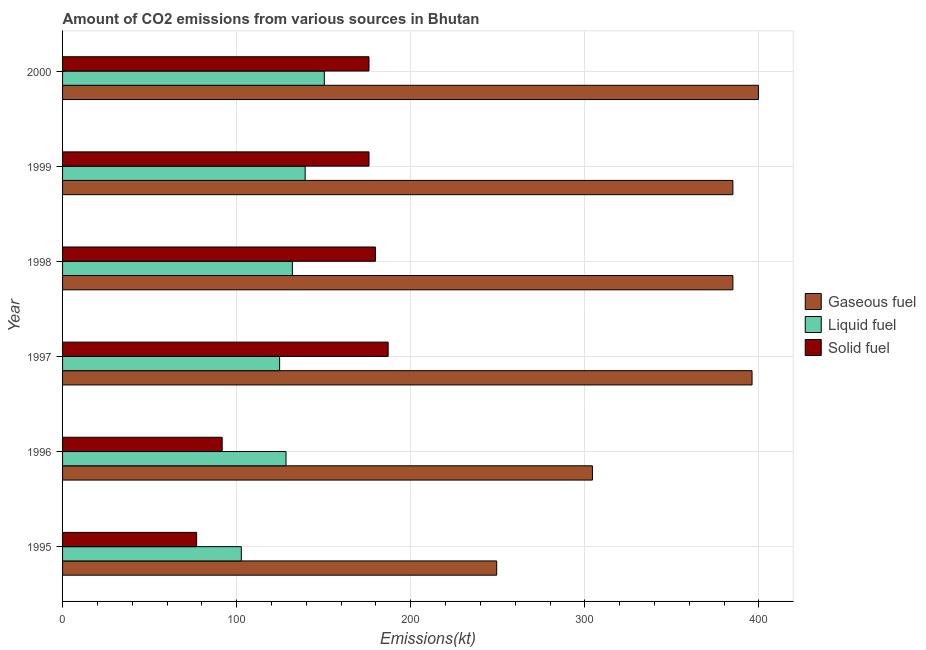How many bars are there on the 1st tick from the bottom?
Keep it short and to the point. 3. What is the label of the 6th group of bars from the top?
Your response must be concise. 1995. What is the amount of co2 emissions from solid fuel in 1998?
Your answer should be compact. 179.68. Across all years, what is the maximum amount of co2 emissions from solid fuel?
Offer a very short reply. 187.02. Across all years, what is the minimum amount of co2 emissions from gaseous fuel?
Your answer should be very brief. 249.36. In which year was the amount of co2 emissions from gaseous fuel minimum?
Offer a terse response. 1995. What is the total amount of co2 emissions from gaseous fuel in the graph?
Provide a short and direct response. 2119.53. What is the difference between the amount of co2 emissions from gaseous fuel in 1999 and that in 2000?
Offer a terse response. -14.67. What is the difference between the amount of co2 emissions from liquid fuel in 1998 and the amount of co2 emissions from solid fuel in 1999?
Ensure brevity in your answer.  -44. What is the average amount of co2 emissions from solid fuel per year?
Provide a short and direct response. 147.9. In the year 1995, what is the difference between the amount of co2 emissions from liquid fuel and amount of co2 emissions from gaseous fuel?
Your response must be concise. -146.68. What is the difference between the highest and the second highest amount of co2 emissions from solid fuel?
Your answer should be compact. 7.33. What is the difference between the highest and the lowest amount of co2 emissions from liquid fuel?
Provide a succinct answer. 47.67. Is the sum of the amount of co2 emissions from gaseous fuel in 1996 and 1998 greater than the maximum amount of co2 emissions from solid fuel across all years?
Provide a succinct answer. Yes. What does the 1st bar from the top in 1996 represents?
Keep it short and to the point. Solid fuel. What does the 1st bar from the bottom in 1997 represents?
Your answer should be compact. Gaseous fuel. How many bars are there?
Keep it short and to the point. 18. Are the values on the major ticks of X-axis written in scientific E-notation?
Keep it short and to the point. No. Does the graph contain grids?
Your answer should be very brief. Yes. Where does the legend appear in the graph?
Give a very brief answer. Center right. What is the title of the graph?
Keep it short and to the point. Amount of CO2 emissions from various sources in Bhutan. Does "Spain" appear as one of the legend labels in the graph?
Make the answer very short. No. What is the label or title of the X-axis?
Your answer should be very brief. Emissions(kt). What is the label or title of the Y-axis?
Keep it short and to the point. Year. What is the Emissions(kt) in Gaseous fuel in 1995?
Ensure brevity in your answer.  249.36. What is the Emissions(kt) of Liquid fuel in 1995?
Offer a very short reply. 102.68. What is the Emissions(kt) in Solid fuel in 1995?
Provide a succinct answer. 77.01. What is the Emissions(kt) in Gaseous fuel in 1996?
Your response must be concise. 304.36. What is the Emissions(kt) in Liquid fuel in 1996?
Give a very brief answer. 128.34. What is the Emissions(kt) of Solid fuel in 1996?
Offer a very short reply. 91.67. What is the Emissions(kt) of Gaseous fuel in 1997?
Make the answer very short. 396.04. What is the Emissions(kt) in Liquid fuel in 1997?
Provide a succinct answer. 124.68. What is the Emissions(kt) in Solid fuel in 1997?
Ensure brevity in your answer.  187.02. What is the Emissions(kt) in Gaseous fuel in 1998?
Provide a succinct answer. 385.04. What is the Emissions(kt) of Liquid fuel in 1998?
Keep it short and to the point. 132.01. What is the Emissions(kt) in Solid fuel in 1998?
Provide a short and direct response. 179.68. What is the Emissions(kt) in Gaseous fuel in 1999?
Give a very brief answer. 385.04. What is the Emissions(kt) in Liquid fuel in 1999?
Offer a terse response. 139.35. What is the Emissions(kt) of Solid fuel in 1999?
Make the answer very short. 176.02. What is the Emissions(kt) of Gaseous fuel in 2000?
Keep it short and to the point. 399.7. What is the Emissions(kt) in Liquid fuel in 2000?
Your response must be concise. 150.35. What is the Emissions(kt) in Solid fuel in 2000?
Your answer should be compact. 176.02. Across all years, what is the maximum Emissions(kt) of Gaseous fuel?
Provide a succinct answer. 399.7. Across all years, what is the maximum Emissions(kt) of Liquid fuel?
Make the answer very short. 150.35. Across all years, what is the maximum Emissions(kt) in Solid fuel?
Keep it short and to the point. 187.02. Across all years, what is the minimum Emissions(kt) of Gaseous fuel?
Offer a terse response. 249.36. Across all years, what is the minimum Emissions(kt) of Liquid fuel?
Your answer should be compact. 102.68. Across all years, what is the minimum Emissions(kt) of Solid fuel?
Provide a short and direct response. 77.01. What is the total Emissions(kt) in Gaseous fuel in the graph?
Offer a very short reply. 2119.53. What is the total Emissions(kt) of Liquid fuel in the graph?
Provide a succinct answer. 777.4. What is the total Emissions(kt) in Solid fuel in the graph?
Provide a short and direct response. 887.41. What is the difference between the Emissions(kt) of Gaseous fuel in 1995 and that in 1996?
Provide a short and direct response. -55.01. What is the difference between the Emissions(kt) of Liquid fuel in 1995 and that in 1996?
Offer a very short reply. -25.67. What is the difference between the Emissions(kt) in Solid fuel in 1995 and that in 1996?
Your response must be concise. -14.67. What is the difference between the Emissions(kt) of Gaseous fuel in 1995 and that in 1997?
Provide a succinct answer. -146.68. What is the difference between the Emissions(kt) in Liquid fuel in 1995 and that in 1997?
Give a very brief answer. -22. What is the difference between the Emissions(kt) of Solid fuel in 1995 and that in 1997?
Your answer should be very brief. -110.01. What is the difference between the Emissions(kt) of Gaseous fuel in 1995 and that in 1998?
Make the answer very short. -135.68. What is the difference between the Emissions(kt) in Liquid fuel in 1995 and that in 1998?
Give a very brief answer. -29.34. What is the difference between the Emissions(kt) in Solid fuel in 1995 and that in 1998?
Give a very brief answer. -102.68. What is the difference between the Emissions(kt) of Gaseous fuel in 1995 and that in 1999?
Keep it short and to the point. -135.68. What is the difference between the Emissions(kt) in Liquid fuel in 1995 and that in 1999?
Ensure brevity in your answer.  -36.67. What is the difference between the Emissions(kt) in Solid fuel in 1995 and that in 1999?
Give a very brief answer. -99.01. What is the difference between the Emissions(kt) of Gaseous fuel in 1995 and that in 2000?
Offer a very short reply. -150.35. What is the difference between the Emissions(kt) of Liquid fuel in 1995 and that in 2000?
Provide a short and direct response. -47.67. What is the difference between the Emissions(kt) in Solid fuel in 1995 and that in 2000?
Give a very brief answer. -99.01. What is the difference between the Emissions(kt) in Gaseous fuel in 1996 and that in 1997?
Keep it short and to the point. -91.67. What is the difference between the Emissions(kt) in Liquid fuel in 1996 and that in 1997?
Offer a terse response. 3.67. What is the difference between the Emissions(kt) of Solid fuel in 1996 and that in 1997?
Your answer should be compact. -95.34. What is the difference between the Emissions(kt) in Gaseous fuel in 1996 and that in 1998?
Offer a very short reply. -80.67. What is the difference between the Emissions(kt) of Liquid fuel in 1996 and that in 1998?
Keep it short and to the point. -3.67. What is the difference between the Emissions(kt) of Solid fuel in 1996 and that in 1998?
Your answer should be very brief. -88.01. What is the difference between the Emissions(kt) of Gaseous fuel in 1996 and that in 1999?
Offer a terse response. -80.67. What is the difference between the Emissions(kt) in Liquid fuel in 1996 and that in 1999?
Provide a short and direct response. -11. What is the difference between the Emissions(kt) in Solid fuel in 1996 and that in 1999?
Ensure brevity in your answer.  -84.34. What is the difference between the Emissions(kt) in Gaseous fuel in 1996 and that in 2000?
Keep it short and to the point. -95.34. What is the difference between the Emissions(kt) in Liquid fuel in 1996 and that in 2000?
Provide a short and direct response. -22. What is the difference between the Emissions(kt) of Solid fuel in 1996 and that in 2000?
Provide a succinct answer. -84.34. What is the difference between the Emissions(kt) in Gaseous fuel in 1997 and that in 1998?
Provide a short and direct response. 11. What is the difference between the Emissions(kt) of Liquid fuel in 1997 and that in 1998?
Offer a very short reply. -7.33. What is the difference between the Emissions(kt) of Solid fuel in 1997 and that in 1998?
Provide a short and direct response. 7.33. What is the difference between the Emissions(kt) of Gaseous fuel in 1997 and that in 1999?
Offer a terse response. 11. What is the difference between the Emissions(kt) in Liquid fuel in 1997 and that in 1999?
Keep it short and to the point. -14.67. What is the difference between the Emissions(kt) of Solid fuel in 1997 and that in 1999?
Your response must be concise. 11. What is the difference between the Emissions(kt) of Gaseous fuel in 1997 and that in 2000?
Keep it short and to the point. -3.67. What is the difference between the Emissions(kt) of Liquid fuel in 1997 and that in 2000?
Ensure brevity in your answer.  -25.67. What is the difference between the Emissions(kt) of Solid fuel in 1997 and that in 2000?
Give a very brief answer. 11. What is the difference between the Emissions(kt) of Liquid fuel in 1998 and that in 1999?
Provide a succinct answer. -7.33. What is the difference between the Emissions(kt) in Solid fuel in 1998 and that in 1999?
Give a very brief answer. 3.67. What is the difference between the Emissions(kt) of Gaseous fuel in 1998 and that in 2000?
Keep it short and to the point. -14.67. What is the difference between the Emissions(kt) in Liquid fuel in 1998 and that in 2000?
Give a very brief answer. -18.34. What is the difference between the Emissions(kt) of Solid fuel in 1998 and that in 2000?
Make the answer very short. 3.67. What is the difference between the Emissions(kt) of Gaseous fuel in 1999 and that in 2000?
Make the answer very short. -14.67. What is the difference between the Emissions(kt) of Liquid fuel in 1999 and that in 2000?
Your answer should be very brief. -11. What is the difference between the Emissions(kt) of Gaseous fuel in 1995 and the Emissions(kt) of Liquid fuel in 1996?
Your response must be concise. 121.01. What is the difference between the Emissions(kt) of Gaseous fuel in 1995 and the Emissions(kt) of Solid fuel in 1996?
Offer a terse response. 157.68. What is the difference between the Emissions(kt) of Liquid fuel in 1995 and the Emissions(kt) of Solid fuel in 1996?
Your response must be concise. 11. What is the difference between the Emissions(kt) of Gaseous fuel in 1995 and the Emissions(kt) of Liquid fuel in 1997?
Your answer should be compact. 124.68. What is the difference between the Emissions(kt) in Gaseous fuel in 1995 and the Emissions(kt) in Solid fuel in 1997?
Make the answer very short. 62.34. What is the difference between the Emissions(kt) of Liquid fuel in 1995 and the Emissions(kt) of Solid fuel in 1997?
Provide a short and direct response. -84.34. What is the difference between the Emissions(kt) in Gaseous fuel in 1995 and the Emissions(kt) in Liquid fuel in 1998?
Your answer should be compact. 117.34. What is the difference between the Emissions(kt) in Gaseous fuel in 1995 and the Emissions(kt) in Solid fuel in 1998?
Your response must be concise. 69.67. What is the difference between the Emissions(kt) in Liquid fuel in 1995 and the Emissions(kt) in Solid fuel in 1998?
Provide a succinct answer. -77.01. What is the difference between the Emissions(kt) of Gaseous fuel in 1995 and the Emissions(kt) of Liquid fuel in 1999?
Keep it short and to the point. 110.01. What is the difference between the Emissions(kt) of Gaseous fuel in 1995 and the Emissions(kt) of Solid fuel in 1999?
Your answer should be compact. 73.34. What is the difference between the Emissions(kt) of Liquid fuel in 1995 and the Emissions(kt) of Solid fuel in 1999?
Your response must be concise. -73.34. What is the difference between the Emissions(kt) in Gaseous fuel in 1995 and the Emissions(kt) in Liquid fuel in 2000?
Your response must be concise. 99.01. What is the difference between the Emissions(kt) in Gaseous fuel in 1995 and the Emissions(kt) in Solid fuel in 2000?
Provide a succinct answer. 73.34. What is the difference between the Emissions(kt) in Liquid fuel in 1995 and the Emissions(kt) in Solid fuel in 2000?
Offer a very short reply. -73.34. What is the difference between the Emissions(kt) in Gaseous fuel in 1996 and the Emissions(kt) in Liquid fuel in 1997?
Offer a terse response. 179.68. What is the difference between the Emissions(kt) in Gaseous fuel in 1996 and the Emissions(kt) in Solid fuel in 1997?
Your response must be concise. 117.34. What is the difference between the Emissions(kt) of Liquid fuel in 1996 and the Emissions(kt) of Solid fuel in 1997?
Keep it short and to the point. -58.67. What is the difference between the Emissions(kt) in Gaseous fuel in 1996 and the Emissions(kt) in Liquid fuel in 1998?
Ensure brevity in your answer.  172.35. What is the difference between the Emissions(kt) in Gaseous fuel in 1996 and the Emissions(kt) in Solid fuel in 1998?
Your answer should be very brief. 124.68. What is the difference between the Emissions(kt) of Liquid fuel in 1996 and the Emissions(kt) of Solid fuel in 1998?
Your response must be concise. -51.34. What is the difference between the Emissions(kt) in Gaseous fuel in 1996 and the Emissions(kt) in Liquid fuel in 1999?
Keep it short and to the point. 165.01. What is the difference between the Emissions(kt) of Gaseous fuel in 1996 and the Emissions(kt) of Solid fuel in 1999?
Your answer should be very brief. 128.34. What is the difference between the Emissions(kt) of Liquid fuel in 1996 and the Emissions(kt) of Solid fuel in 1999?
Provide a succinct answer. -47.67. What is the difference between the Emissions(kt) in Gaseous fuel in 1996 and the Emissions(kt) in Liquid fuel in 2000?
Offer a very short reply. 154.01. What is the difference between the Emissions(kt) of Gaseous fuel in 1996 and the Emissions(kt) of Solid fuel in 2000?
Keep it short and to the point. 128.34. What is the difference between the Emissions(kt) in Liquid fuel in 1996 and the Emissions(kt) in Solid fuel in 2000?
Ensure brevity in your answer.  -47.67. What is the difference between the Emissions(kt) in Gaseous fuel in 1997 and the Emissions(kt) in Liquid fuel in 1998?
Keep it short and to the point. 264.02. What is the difference between the Emissions(kt) in Gaseous fuel in 1997 and the Emissions(kt) in Solid fuel in 1998?
Your response must be concise. 216.35. What is the difference between the Emissions(kt) in Liquid fuel in 1997 and the Emissions(kt) in Solid fuel in 1998?
Provide a short and direct response. -55.01. What is the difference between the Emissions(kt) in Gaseous fuel in 1997 and the Emissions(kt) in Liquid fuel in 1999?
Keep it short and to the point. 256.69. What is the difference between the Emissions(kt) of Gaseous fuel in 1997 and the Emissions(kt) of Solid fuel in 1999?
Your response must be concise. 220.02. What is the difference between the Emissions(kt) in Liquid fuel in 1997 and the Emissions(kt) in Solid fuel in 1999?
Provide a short and direct response. -51.34. What is the difference between the Emissions(kt) of Gaseous fuel in 1997 and the Emissions(kt) of Liquid fuel in 2000?
Your answer should be compact. 245.69. What is the difference between the Emissions(kt) in Gaseous fuel in 1997 and the Emissions(kt) in Solid fuel in 2000?
Your response must be concise. 220.02. What is the difference between the Emissions(kt) of Liquid fuel in 1997 and the Emissions(kt) of Solid fuel in 2000?
Ensure brevity in your answer.  -51.34. What is the difference between the Emissions(kt) of Gaseous fuel in 1998 and the Emissions(kt) of Liquid fuel in 1999?
Make the answer very short. 245.69. What is the difference between the Emissions(kt) in Gaseous fuel in 1998 and the Emissions(kt) in Solid fuel in 1999?
Your response must be concise. 209.02. What is the difference between the Emissions(kt) in Liquid fuel in 1998 and the Emissions(kt) in Solid fuel in 1999?
Ensure brevity in your answer.  -44. What is the difference between the Emissions(kt) in Gaseous fuel in 1998 and the Emissions(kt) in Liquid fuel in 2000?
Provide a short and direct response. 234.69. What is the difference between the Emissions(kt) of Gaseous fuel in 1998 and the Emissions(kt) of Solid fuel in 2000?
Offer a very short reply. 209.02. What is the difference between the Emissions(kt) in Liquid fuel in 1998 and the Emissions(kt) in Solid fuel in 2000?
Provide a short and direct response. -44. What is the difference between the Emissions(kt) in Gaseous fuel in 1999 and the Emissions(kt) in Liquid fuel in 2000?
Provide a succinct answer. 234.69. What is the difference between the Emissions(kt) in Gaseous fuel in 1999 and the Emissions(kt) in Solid fuel in 2000?
Provide a succinct answer. 209.02. What is the difference between the Emissions(kt) in Liquid fuel in 1999 and the Emissions(kt) in Solid fuel in 2000?
Offer a very short reply. -36.67. What is the average Emissions(kt) of Gaseous fuel per year?
Ensure brevity in your answer.  353.25. What is the average Emissions(kt) of Liquid fuel per year?
Your answer should be very brief. 129.57. What is the average Emissions(kt) of Solid fuel per year?
Offer a very short reply. 147.9. In the year 1995, what is the difference between the Emissions(kt) in Gaseous fuel and Emissions(kt) in Liquid fuel?
Your answer should be very brief. 146.68. In the year 1995, what is the difference between the Emissions(kt) of Gaseous fuel and Emissions(kt) of Solid fuel?
Keep it short and to the point. 172.35. In the year 1995, what is the difference between the Emissions(kt) of Liquid fuel and Emissions(kt) of Solid fuel?
Make the answer very short. 25.67. In the year 1996, what is the difference between the Emissions(kt) in Gaseous fuel and Emissions(kt) in Liquid fuel?
Make the answer very short. 176.02. In the year 1996, what is the difference between the Emissions(kt) in Gaseous fuel and Emissions(kt) in Solid fuel?
Your answer should be very brief. 212.69. In the year 1996, what is the difference between the Emissions(kt) in Liquid fuel and Emissions(kt) in Solid fuel?
Ensure brevity in your answer.  36.67. In the year 1997, what is the difference between the Emissions(kt) in Gaseous fuel and Emissions(kt) in Liquid fuel?
Offer a terse response. 271.36. In the year 1997, what is the difference between the Emissions(kt) in Gaseous fuel and Emissions(kt) in Solid fuel?
Your response must be concise. 209.02. In the year 1997, what is the difference between the Emissions(kt) of Liquid fuel and Emissions(kt) of Solid fuel?
Keep it short and to the point. -62.34. In the year 1998, what is the difference between the Emissions(kt) of Gaseous fuel and Emissions(kt) of Liquid fuel?
Provide a succinct answer. 253.02. In the year 1998, what is the difference between the Emissions(kt) of Gaseous fuel and Emissions(kt) of Solid fuel?
Offer a very short reply. 205.35. In the year 1998, what is the difference between the Emissions(kt) in Liquid fuel and Emissions(kt) in Solid fuel?
Make the answer very short. -47.67. In the year 1999, what is the difference between the Emissions(kt) in Gaseous fuel and Emissions(kt) in Liquid fuel?
Make the answer very short. 245.69. In the year 1999, what is the difference between the Emissions(kt) of Gaseous fuel and Emissions(kt) of Solid fuel?
Make the answer very short. 209.02. In the year 1999, what is the difference between the Emissions(kt) in Liquid fuel and Emissions(kt) in Solid fuel?
Your response must be concise. -36.67. In the year 2000, what is the difference between the Emissions(kt) in Gaseous fuel and Emissions(kt) in Liquid fuel?
Ensure brevity in your answer.  249.36. In the year 2000, what is the difference between the Emissions(kt) in Gaseous fuel and Emissions(kt) in Solid fuel?
Give a very brief answer. 223.69. In the year 2000, what is the difference between the Emissions(kt) in Liquid fuel and Emissions(kt) in Solid fuel?
Ensure brevity in your answer.  -25.67. What is the ratio of the Emissions(kt) of Gaseous fuel in 1995 to that in 1996?
Your answer should be very brief. 0.82. What is the ratio of the Emissions(kt) in Liquid fuel in 1995 to that in 1996?
Give a very brief answer. 0.8. What is the ratio of the Emissions(kt) of Solid fuel in 1995 to that in 1996?
Keep it short and to the point. 0.84. What is the ratio of the Emissions(kt) of Gaseous fuel in 1995 to that in 1997?
Offer a very short reply. 0.63. What is the ratio of the Emissions(kt) in Liquid fuel in 1995 to that in 1997?
Your answer should be compact. 0.82. What is the ratio of the Emissions(kt) in Solid fuel in 1995 to that in 1997?
Offer a very short reply. 0.41. What is the ratio of the Emissions(kt) of Gaseous fuel in 1995 to that in 1998?
Make the answer very short. 0.65. What is the ratio of the Emissions(kt) in Liquid fuel in 1995 to that in 1998?
Offer a very short reply. 0.78. What is the ratio of the Emissions(kt) in Solid fuel in 1995 to that in 1998?
Offer a very short reply. 0.43. What is the ratio of the Emissions(kt) in Gaseous fuel in 1995 to that in 1999?
Offer a very short reply. 0.65. What is the ratio of the Emissions(kt) in Liquid fuel in 1995 to that in 1999?
Ensure brevity in your answer.  0.74. What is the ratio of the Emissions(kt) of Solid fuel in 1995 to that in 1999?
Offer a terse response. 0.44. What is the ratio of the Emissions(kt) in Gaseous fuel in 1995 to that in 2000?
Your response must be concise. 0.62. What is the ratio of the Emissions(kt) of Liquid fuel in 1995 to that in 2000?
Make the answer very short. 0.68. What is the ratio of the Emissions(kt) of Solid fuel in 1995 to that in 2000?
Offer a very short reply. 0.44. What is the ratio of the Emissions(kt) in Gaseous fuel in 1996 to that in 1997?
Offer a very short reply. 0.77. What is the ratio of the Emissions(kt) of Liquid fuel in 1996 to that in 1997?
Ensure brevity in your answer.  1.03. What is the ratio of the Emissions(kt) in Solid fuel in 1996 to that in 1997?
Offer a very short reply. 0.49. What is the ratio of the Emissions(kt) in Gaseous fuel in 1996 to that in 1998?
Keep it short and to the point. 0.79. What is the ratio of the Emissions(kt) of Liquid fuel in 1996 to that in 1998?
Your answer should be compact. 0.97. What is the ratio of the Emissions(kt) in Solid fuel in 1996 to that in 1998?
Your answer should be very brief. 0.51. What is the ratio of the Emissions(kt) in Gaseous fuel in 1996 to that in 1999?
Offer a very short reply. 0.79. What is the ratio of the Emissions(kt) in Liquid fuel in 1996 to that in 1999?
Give a very brief answer. 0.92. What is the ratio of the Emissions(kt) of Solid fuel in 1996 to that in 1999?
Ensure brevity in your answer.  0.52. What is the ratio of the Emissions(kt) of Gaseous fuel in 1996 to that in 2000?
Give a very brief answer. 0.76. What is the ratio of the Emissions(kt) of Liquid fuel in 1996 to that in 2000?
Your answer should be very brief. 0.85. What is the ratio of the Emissions(kt) in Solid fuel in 1996 to that in 2000?
Your answer should be very brief. 0.52. What is the ratio of the Emissions(kt) of Gaseous fuel in 1997 to that in 1998?
Provide a short and direct response. 1.03. What is the ratio of the Emissions(kt) of Solid fuel in 1997 to that in 1998?
Make the answer very short. 1.04. What is the ratio of the Emissions(kt) of Gaseous fuel in 1997 to that in 1999?
Provide a succinct answer. 1.03. What is the ratio of the Emissions(kt) of Liquid fuel in 1997 to that in 1999?
Make the answer very short. 0.89. What is the ratio of the Emissions(kt) of Solid fuel in 1997 to that in 1999?
Provide a short and direct response. 1.06. What is the ratio of the Emissions(kt) in Liquid fuel in 1997 to that in 2000?
Your answer should be compact. 0.83. What is the ratio of the Emissions(kt) of Solid fuel in 1997 to that in 2000?
Provide a succinct answer. 1.06. What is the ratio of the Emissions(kt) in Solid fuel in 1998 to that in 1999?
Ensure brevity in your answer.  1.02. What is the ratio of the Emissions(kt) in Gaseous fuel in 1998 to that in 2000?
Your answer should be compact. 0.96. What is the ratio of the Emissions(kt) in Liquid fuel in 1998 to that in 2000?
Provide a short and direct response. 0.88. What is the ratio of the Emissions(kt) of Solid fuel in 1998 to that in 2000?
Keep it short and to the point. 1.02. What is the ratio of the Emissions(kt) in Gaseous fuel in 1999 to that in 2000?
Offer a terse response. 0.96. What is the ratio of the Emissions(kt) of Liquid fuel in 1999 to that in 2000?
Offer a terse response. 0.93. What is the ratio of the Emissions(kt) of Solid fuel in 1999 to that in 2000?
Your response must be concise. 1. What is the difference between the highest and the second highest Emissions(kt) in Gaseous fuel?
Your answer should be very brief. 3.67. What is the difference between the highest and the second highest Emissions(kt) of Liquid fuel?
Provide a succinct answer. 11. What is the difference between the highest and the second highest Emissions(kt) of Solid fuel?
Your answer should be very brief. 7.33. What is the difference between the highest and the lowest Emissions(kt) in Gaseous fuel?
Offer a terse response. 150.35. What is the difference between the highest and the lowest Emissions(kt) of Liquid fuel?
Ensure brevity in your answer.  47.67. What is the difference between the highest and the lowest Emissions(kt) in Solid fuel?
Your response must be concise. 110.01. 